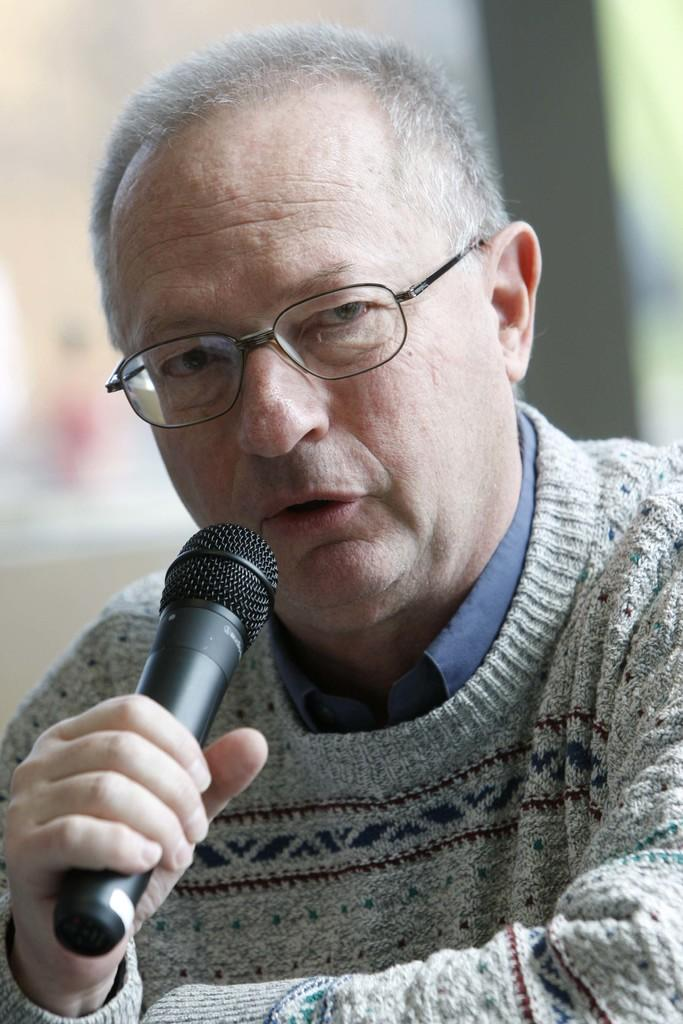What is the main subject of the image? The main subject of the image is a man. What is the man holding in the image? The man is holding a microphone. Can you describe the man's appearance in the image? The man is wearing spectacles and a grey-colored sweater. What type of root can be seen growing from the man's head in the image? There is no root growing from the man's head in the image. 